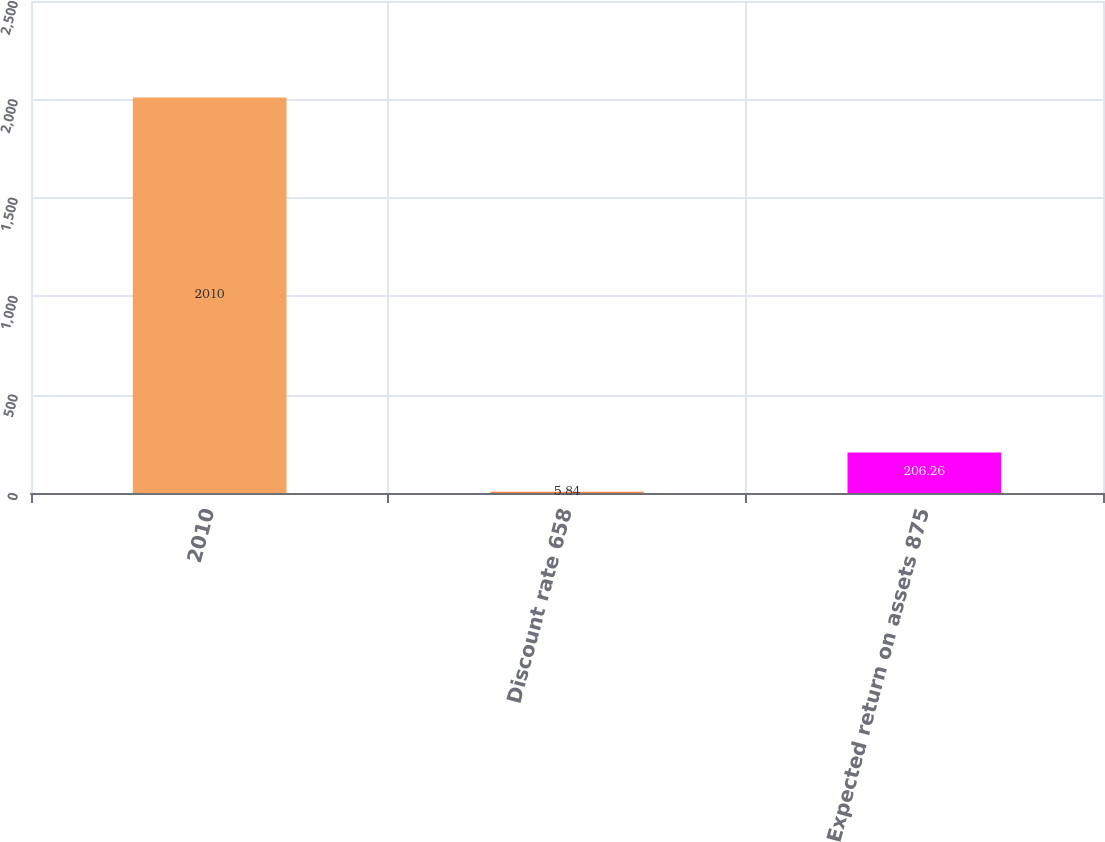Convert chart to OTSL. <chart><loc_0><loc_0><loc_500><loc_500><bar_chart><fcel>2010<fcel>Discount rate 658<fcel>Expected return on assets 875<nl><fcel>2010<fcel>5.84<fcel>206.26<nl></chart> 